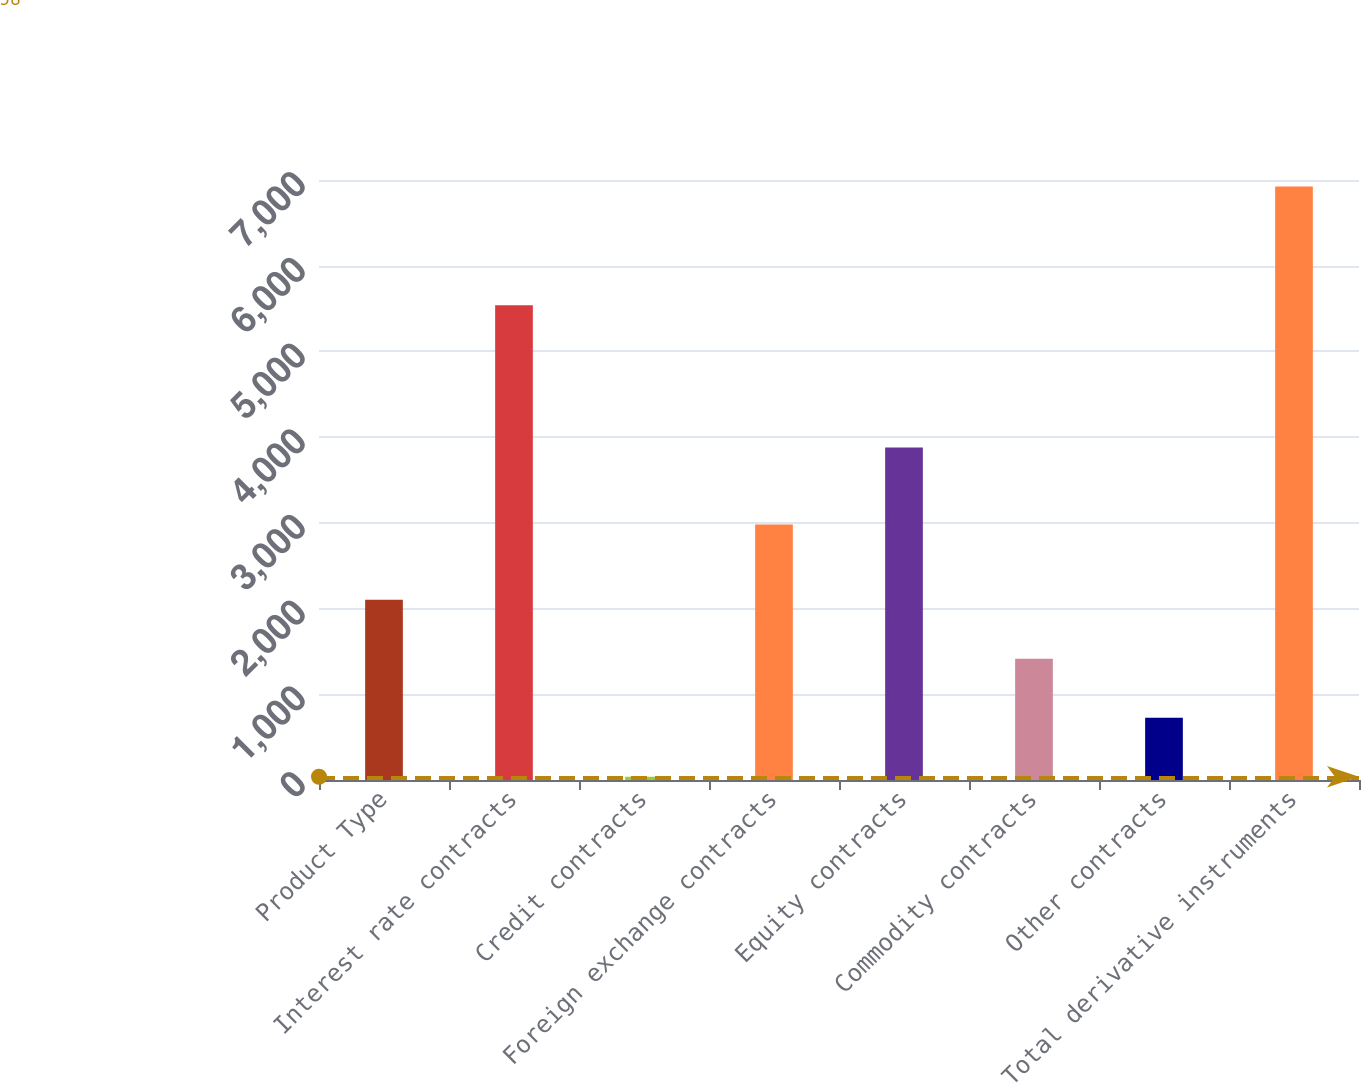Convert chart to OTSL. <chart><loc_0><loc_0><loc_500><loc_500><bar_chart><fcel>Product Type<fcel>Interest rate contracts<fcel>Credit contracts<fcel>Foreign exchange contracts<fcel>Equity contracts<fcel>Commodity contracts<fcel>Other contracts<fcel>Total derivative instruments<nl><fcel>2103.5<fcel>5538<fcel>38<fcel>2982<fcel>3880<fcel>1415<fcel>726.5<fcel>6923<nl></chart> 